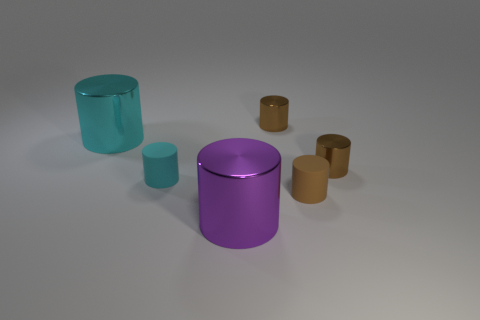How many brown cylinders must be subtracted to get 1 brown cylinders? 2 Subtract all purple metal cylinders. How many cylinders are left? 5 Subtract all green blocks. How many brown cylinders are left? 3 Add 2 large green spheres. How many objects exist? 8 Subtract 5 cylinders. How many cylinders are left? 1 Subtract all cyan cylinders. How many cylinders are left? 4 Subtract 0 brown cubes. How many objects are left? 6 Subtract all red cylinders. Subtract all gray spheres. How many cylinders are left? 6 Subtract all big cyan cylinders. Subtract all small objects. How many objects are left? 1 Add 5 large purple cylinders. How many large purple cylinders are left? 6 